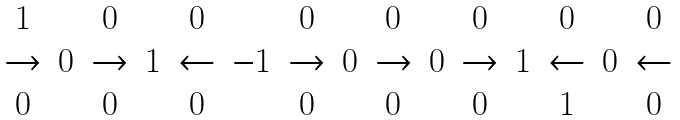Convert formula to latex. <formula><loc_0><loc_0><loc_500><loc_500>\begin{array} { c c c c c c c c c c c c c c c } 1 & & 0 & & 0 & & 0 & & 0 & & 0 & & 0 & & 0 \\ \rightarrow & 0 & \rightarrow & 1 & \leftarrow & - 1 & \rightarrow & 0 & \rightarrow & 0 & \rightarrow & 1 & \leftarrow & 0 & \leftarrow \\ 0 & & 0 & & 0 & & 0 & & 0 & & 0 & & 1 & & 0 \end{array}</formula> 